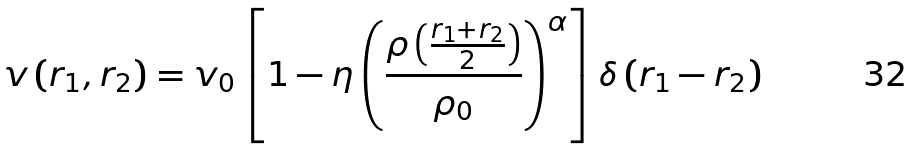<formula> <loc_0><loc_0><loc_500><loc_500>v \left ( { r } _ { 1 } , { r } _ { 2 } \right ) = v _ { 0 } \left [ 1 - \eta \left ( \frac { \rho \left ( \frac { { r } _ { 1 } + { r } _ { 2 } } { 2 } \right ) } { \rho _ { 0 } } \right ) ^ { \alpha } \right ] \delta \left ( { r } _ { 1 } - { r } _ { 2 } \right )</formula> 